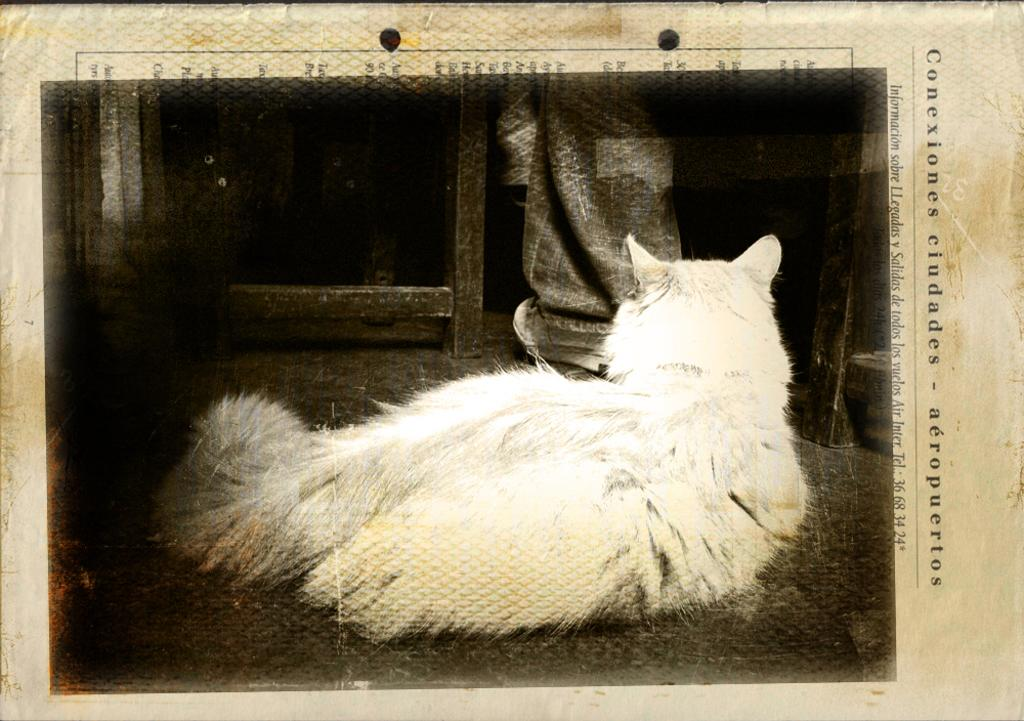What type of animal is sitting in the image? There is a white dog sitting in the image. What is the person in the image doing? The person is standing at a table in the image. What is located at the bottom of the image? There is a paper at the bottom of the image. What can be read on the paper in the image? There is text on the paper in the image. What type of operation is being performed on the dog in the image? There is no operation being performed on the dog in the image; it is simply sitting. What type of destruction is visible in the image? There is no destruction visible in the image; it is a peaceful scene with a dog sitting and a person standing at a table. 